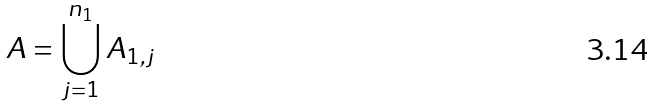Convert formula to latex. <formula><loc_0><loc_0><loc_500><loc_500>A = \bigcup _ { j = 1 } ^ { n _ { 1 } } A _ { 1 , j }</formula> 